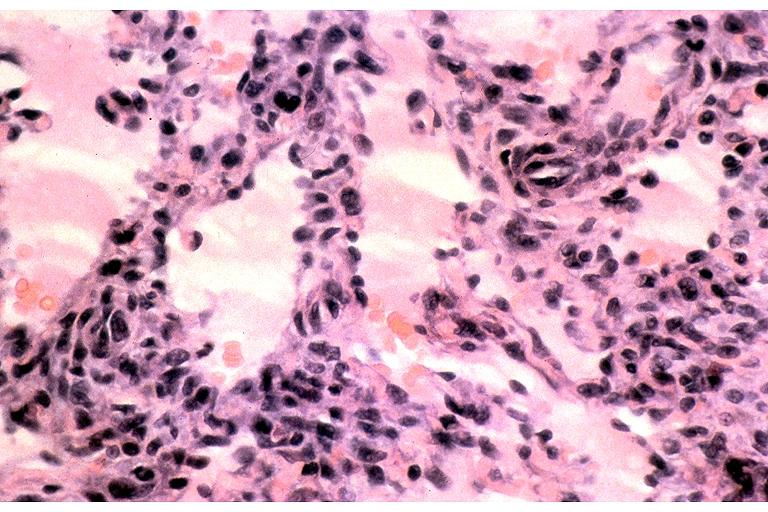what is present?
Answer the question using a single word or phrase. Oral 